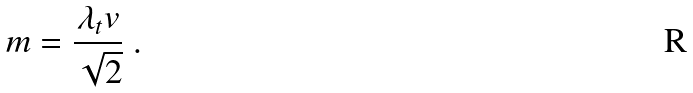<formula> <loc_0><loc_0><loc_500><loc_500>m = \frac { \lambda _ { t } v } { \sqrt { 2 } } \ .</formula> 